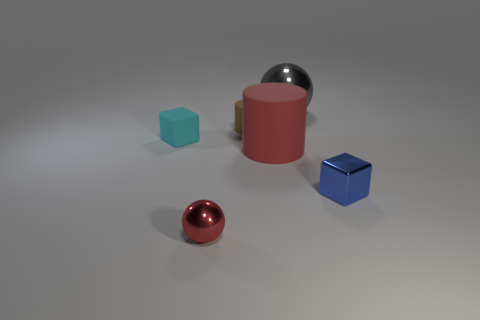There is a large gray object that is the same shape as the small red shiny thing; what material is it?
Your response must be concise. Metal. What number of objects are cubes in front of the cyan object or shiny spheres?
Keep it short and to the point. 3. What shape is the small cyan thing that is made of the same material as the tiny cylinder?
Your answer should be very brief. Cube. How many tiny matte objects are the same shape as the large red rubber thing?
Keep it short and to the point. 1. What material is the tiny sphere?
Provide a short and direct response. Metal. There is a tiny metallic sphere; does it have the same color as the large matte object that is right of the small red metal thing?
Make the answer very short. Yes. What number of cylinders are either green objects or tiny matte objects?
Ensure brevity in your answer.  1. The small metallic thing that is on the left side of the small blue thing is what color?
Make the answer very short. Red. The tiny object that is the same color as the large rubber object is what shape?
Make the answer very short. Sphere. What number of gray balls have the same size as the cyan rubber object?
Give a very brief answer. 0. 